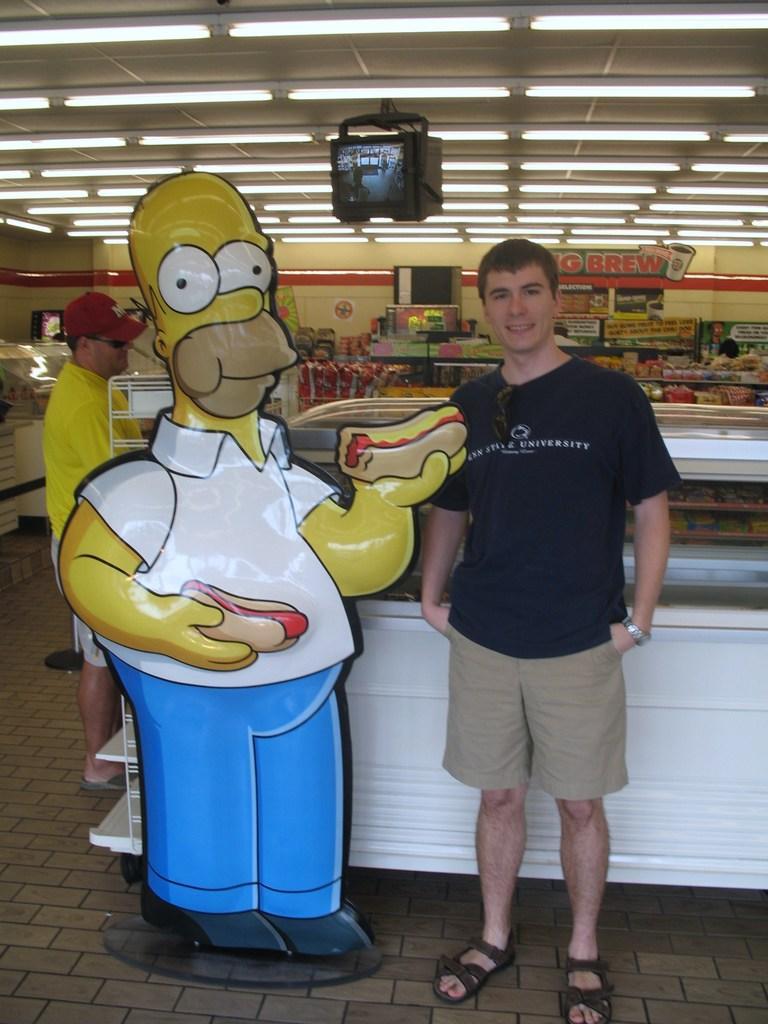Can you describe this image briefly? This image is taken in the food stall. In this image we can see the cartoon of a person holding the food. We can also see two persons standing. In the background we can see the different types of food items placed on the counter. We can also see the black color display object. Image also consists of the wall and also the ceiling with the lights and at the bottom we can see the floor. 